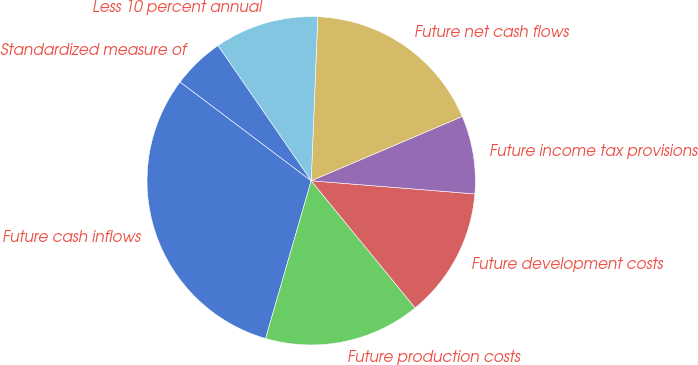<chart> <loc_0><loc_0><loc_500><loc_500><pie_chart><fcel>Future cash inflows<fcel>Future production costs<fcel>Future development costs<fcel>Future income tax provisions<fcel>Future net cash flows<fcel>Less 10 percent annual<fcel>Standardized measure of<nl><fcel>30.8%<fcel>15.39%<fcel>12.82%<fcel>7.68%<fcel>17.96%<fcel>10.25%<fcel>5.11%<nl></chart> 